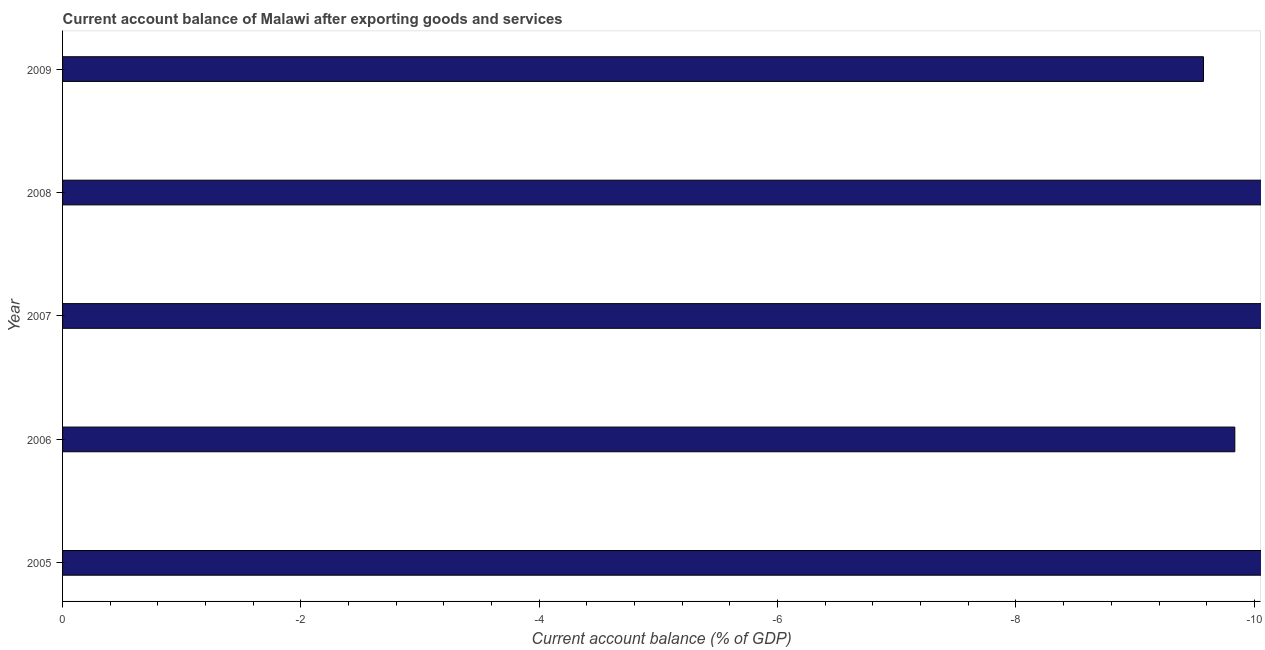Does the graph contain any zero values?
Offer a terse response. Yes. Does the graph contain grids?
Offer a very short reply. No. What is the title of the graph?
Provide a succinct answer. Current account balance of Malawi after exporting goods and services. What is the label or title of the X-axis?
Your answer should be compact. Current account balance (% of GDP). What is the label or title of the Y-axis?
Ensure brevity in your answer.  Year. What is the sum of the current account balance?
Keep it short and to the point. 0. How many bars are there?
Offer a very short reply. 0. How many years are there in the graph?
Your answer should be compact. 5. What is the Current account balance (% of GDP) in 2005?
Give a very brief answer. 0. What is the Current account balance (% of GDP) of 2009?
Offer a terse response. 0. 